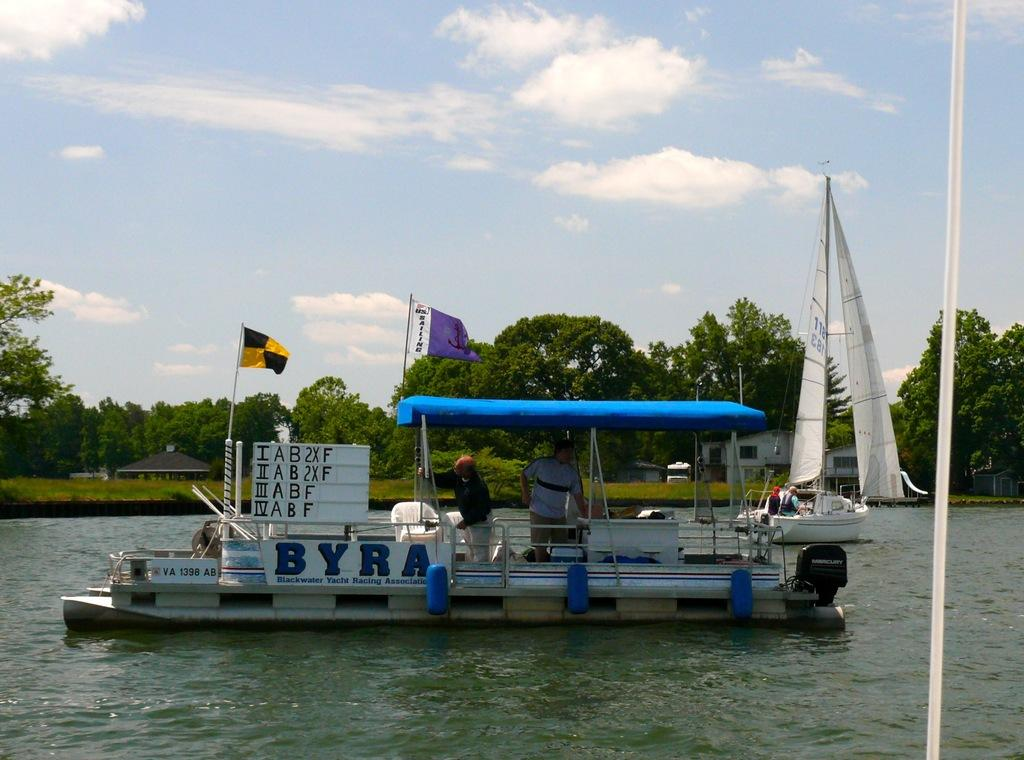What is the main subject of the image? The main subject of the image is a boat. What is the boat doing in the image? The boat is floating on the water. What can be seen in the background of the image? There are trees and the sky visible in the background of the image. What is the opinion of the trees about the boat in the image? Trees do not have opinions, as they are inanimate objects. 